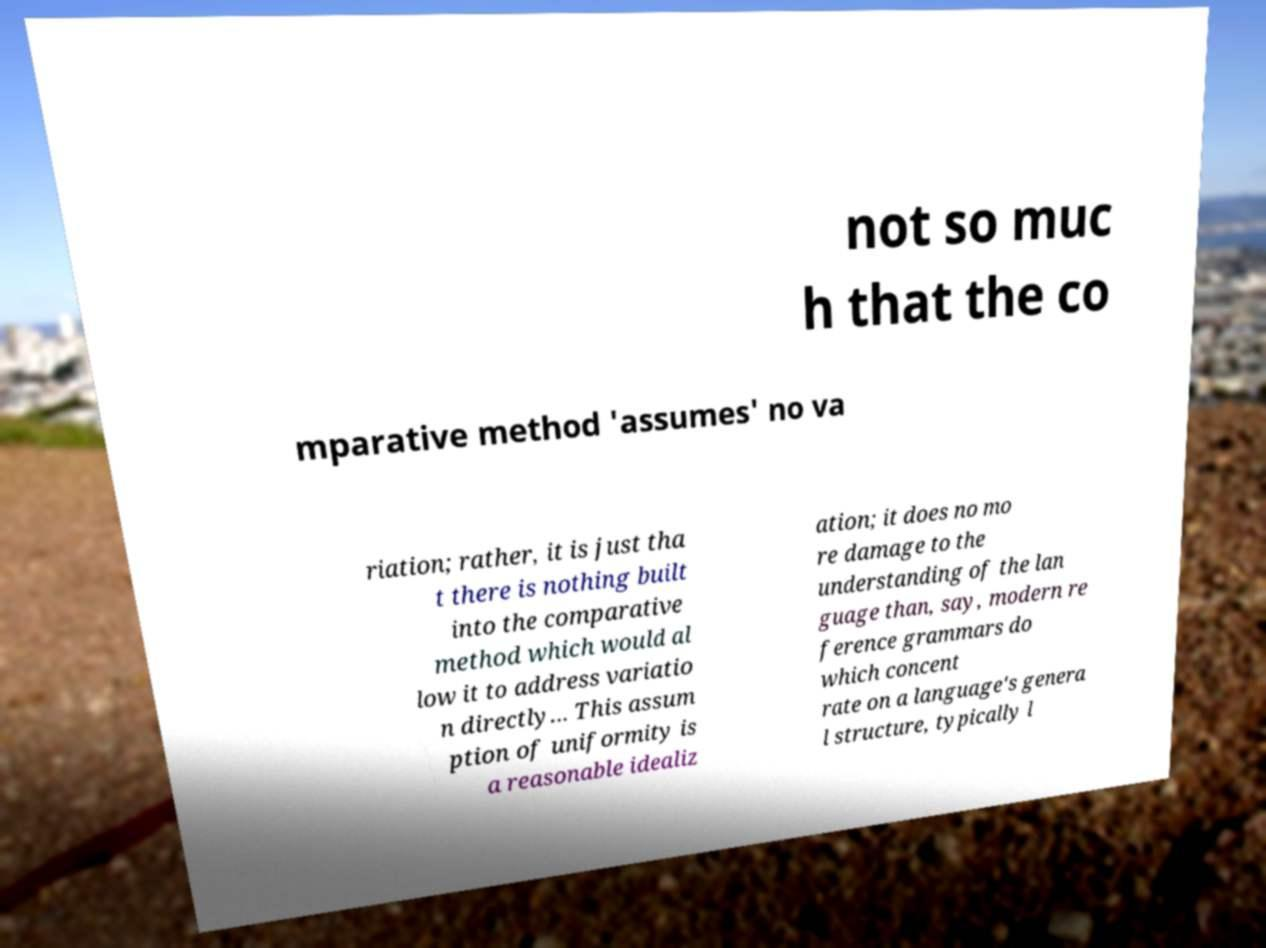For documentation purposes, I need the text within this image transcribed. Could you provide that? not so muc h that the co mparative method 'assumes' no va riation; rather, it is just tha t there is nothing built into the comparative method which would al low it to address variatio n directly... This assum ption of uniformity is a reasonable idealiz ation; it does no mo re damage to the understanding of the lan guage than, say, modern re ference grammars do which concent rate on a language's genera l structure, typically l 